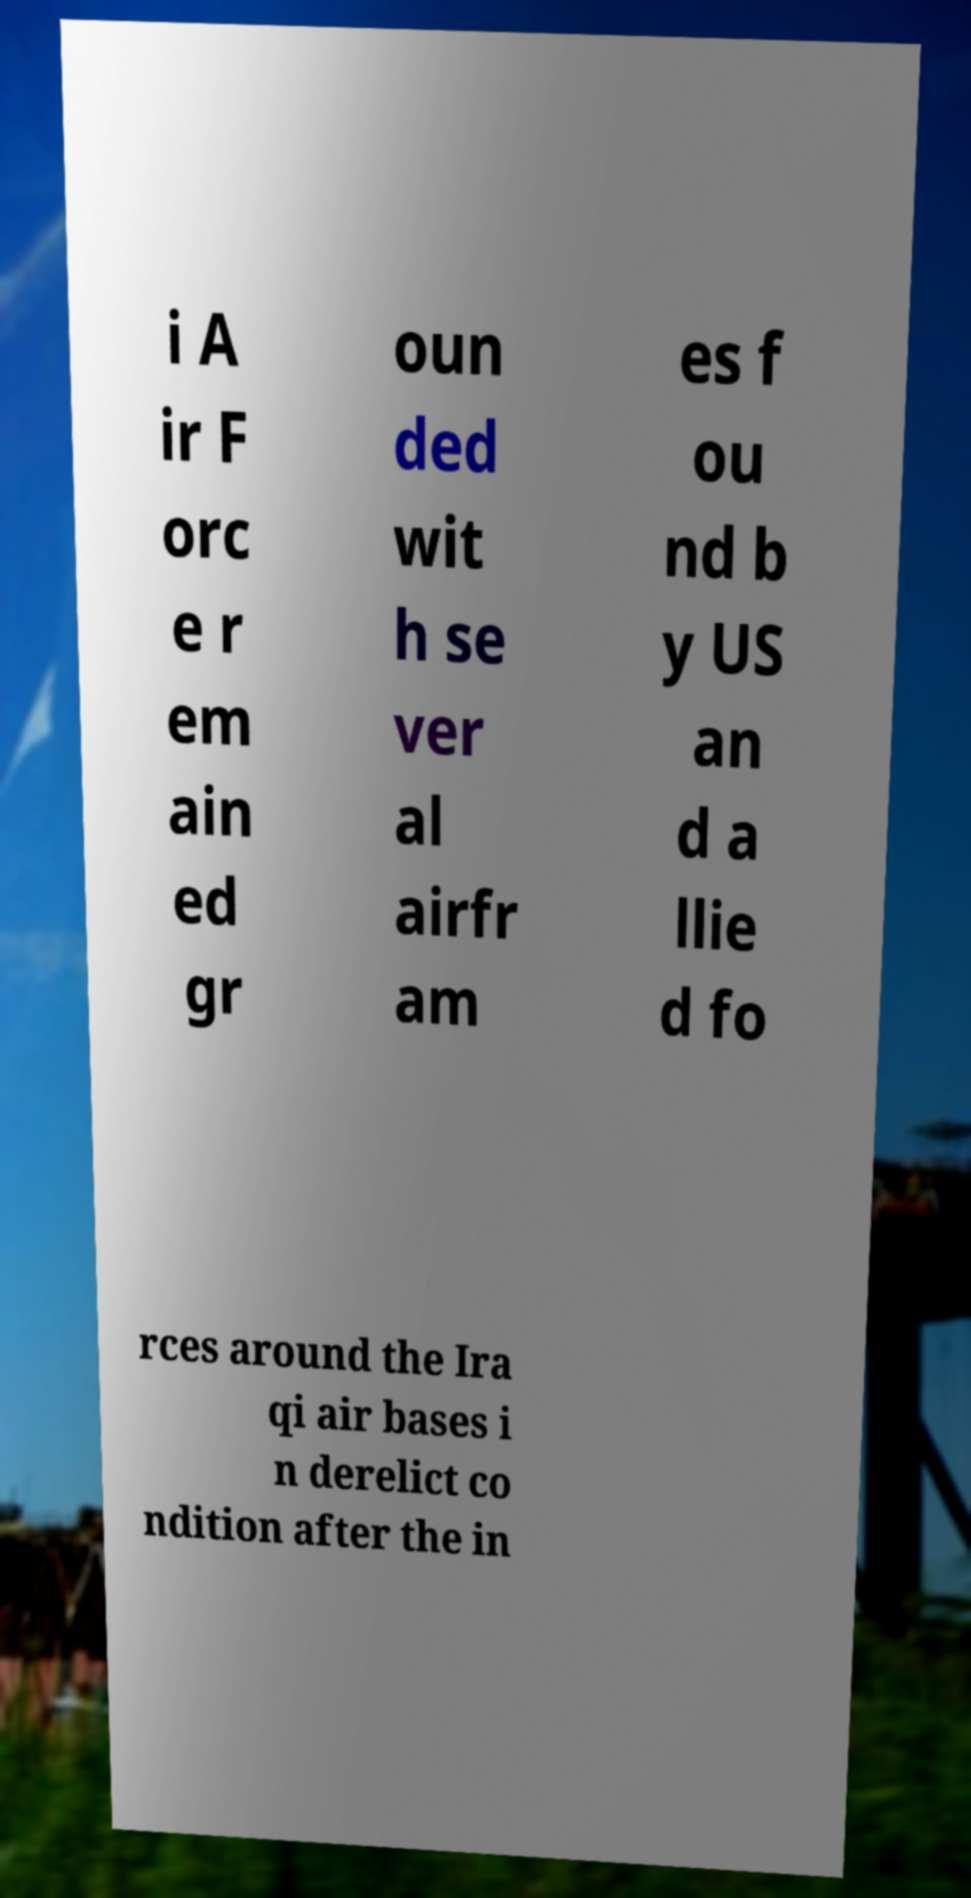Can you read and provide the text displayed in the image?This photo seems to have some interesting text. Can you extract and type it out for me? i A ir F orc e r em ain ed gr oun ded wit h se ver al airfr am es f ou nd b y US an d a llie d fo rces around the Ira qi air bases i n derelict co ndition after the in 